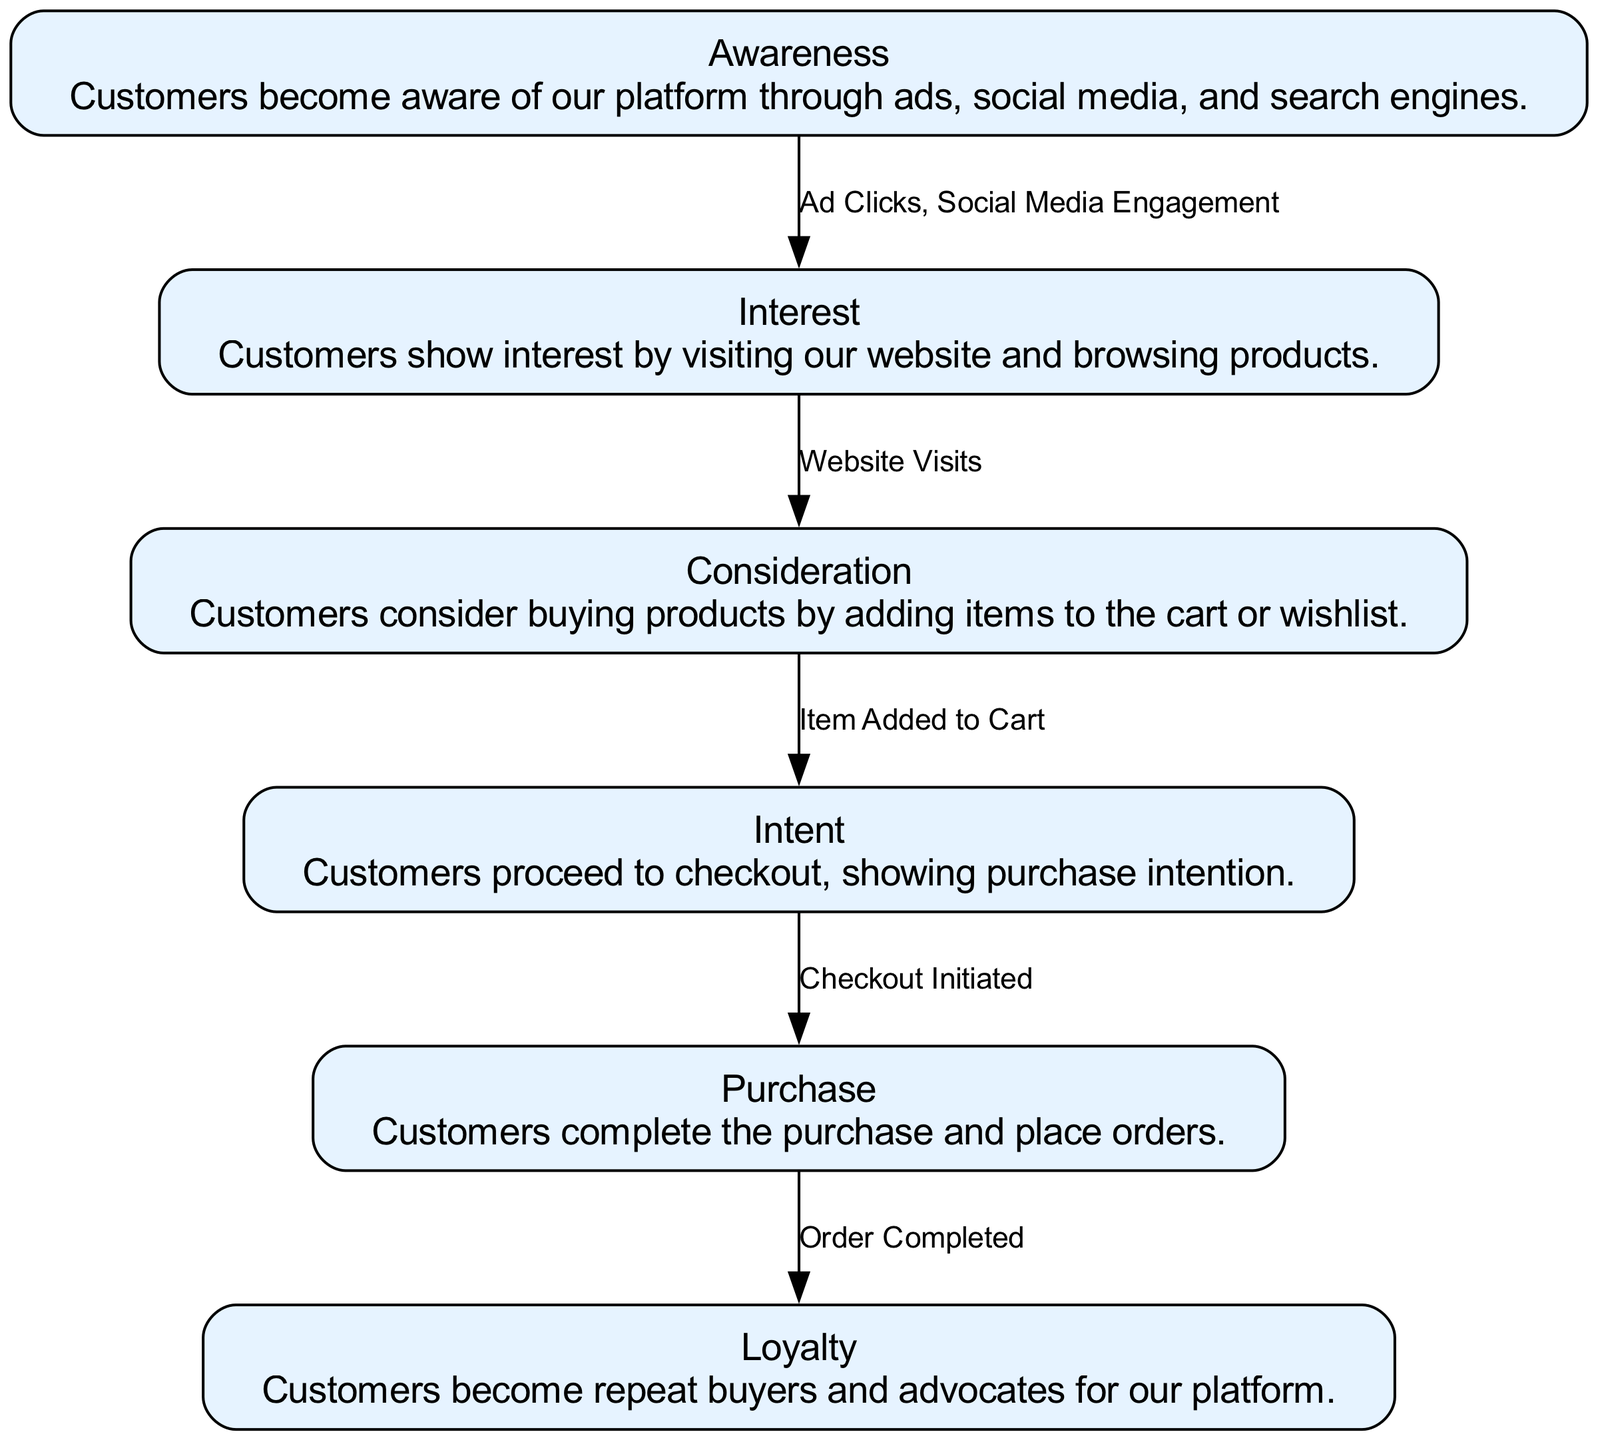What is the first node in the acquisition funnel? The first node listed in the diagram is "Awareness". This can be found at the top of the funnel as it represents the initial stage where customers become aware of the platform.
Answer: Awareness How many nodes are there in total? By counting the nodes listed in the data, we find there are six nodes: Awareness, Interest, Consideration, Intent, Purchase, and Loyalty. Thus, the total is six.
Answer: 6 What represents the transition between 'Consideration' and 'Intent'? The edge between 'Consideration' and 'Intent' is labeled "Item Added to Cart". This transition indicates that customers express their intent by adding products to their carts.
Answer: Item Added to Cart What action leads customers from 'Intent' to 'Purchase'? The transition from 'Intent' to 'Purchase' is represented by the edge labeled "Checkout Initiated", which shows the action of moving towards completing a transaction.
Answer: Checkout Initiated Which node has the final stage of the customer acquisition process? The last node in the diagram, which signifies the completion of the acquisition process, is labeled "Loyalty". This indicates that the customer's journey concludes with becoming a repeated buyer.
Answer: Loyalty How many edges are there in the diagram? The number of edges can be counted by reviewing the connections between nodes, there are five edges that represent transitions between the six nodes listed in the data. Thus, the total is five.
Answer: 5 What is the relationship between 'Awareness' and 'Interest'? The relationship between 'Awareness' and 'Interest' is established through the edge labeled "Ad Clicks, Social Media Engagement", indicating how awareness drives interest through various marketing efforts.
Answer: Ad Clicks, Social Media Engagement What does the 'Purchase' node signify in the funnel? The 'Purchase' node signifies the step where customers complete their transactions by placing orders, in essence marking the successful acquisition of customers.
Answer: Customers complete the purchase and place orders 